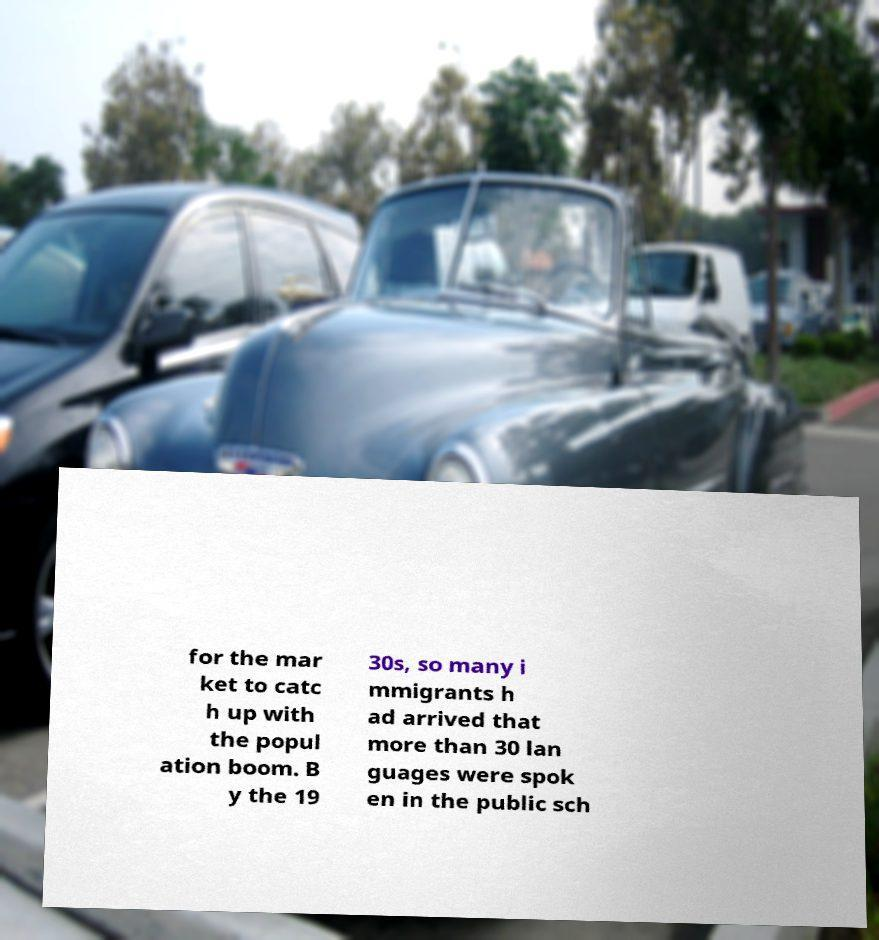For documentation purposes, I need the text within this image transcribed. Could you provide that? for the mar ket to catc h up with the popul ation boom. B y the 19 30s, so many i mmigrants h ad arrived that more than 30 lan guages were spok en in the public sch 